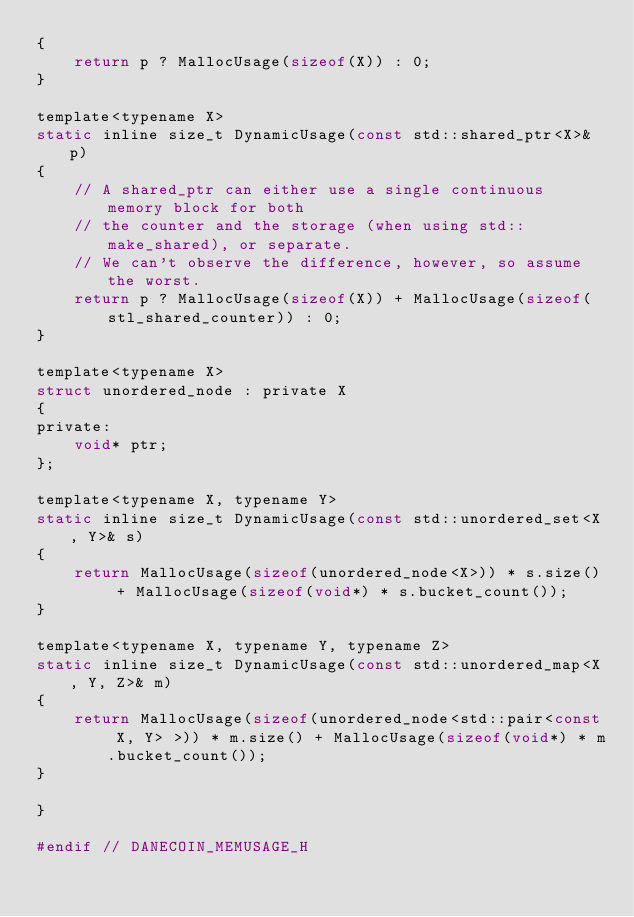<code> <loc_0><loc_0><loc_500><loc_500><_C_>{
    return p ? MallocUsage(sizeof(X)) : 0;
}

template<typename X>
static inline size_t DynamicUsage(const std::shared_ptr<X>& p)
{
    // A shared_ptr can either use a single continuous memory block for both
    // the counter and the storage (when using std::make_shared), or separate.
    // We can't observe the difference, however, so assume the worst.
    return p ? MallocUsage(sizeof(X)) + MallocUsage(sizeof(stl_shared_counter)) : 0;
}

template<typename X>
struct unordered_node : private X
{
private:
    void* ptr;
};

template<typename X, typename Y>
static inline size_t DynamicUsage(const std::unordered_set<X, Y>& s)
{
    return MallocUsage(sizeof(unordered_node<X>)) * s.size() + MallocUsage(sizeof(void*) * s.bucket_count());
}

template<typename X, typename Y, typename Z>
static inline size_t DynamicUsage(const std::unordered_map<X, Y, Z>& m)
{
    return MallocUsage(sizeof(unordered_node<std::pair<const X, Y> >)) * m.size() + MallocUsage(sizeof(void*) * m.bucket_count());
}

}

#endif // DANECOIN_MEMUSAGE_H
</code> 